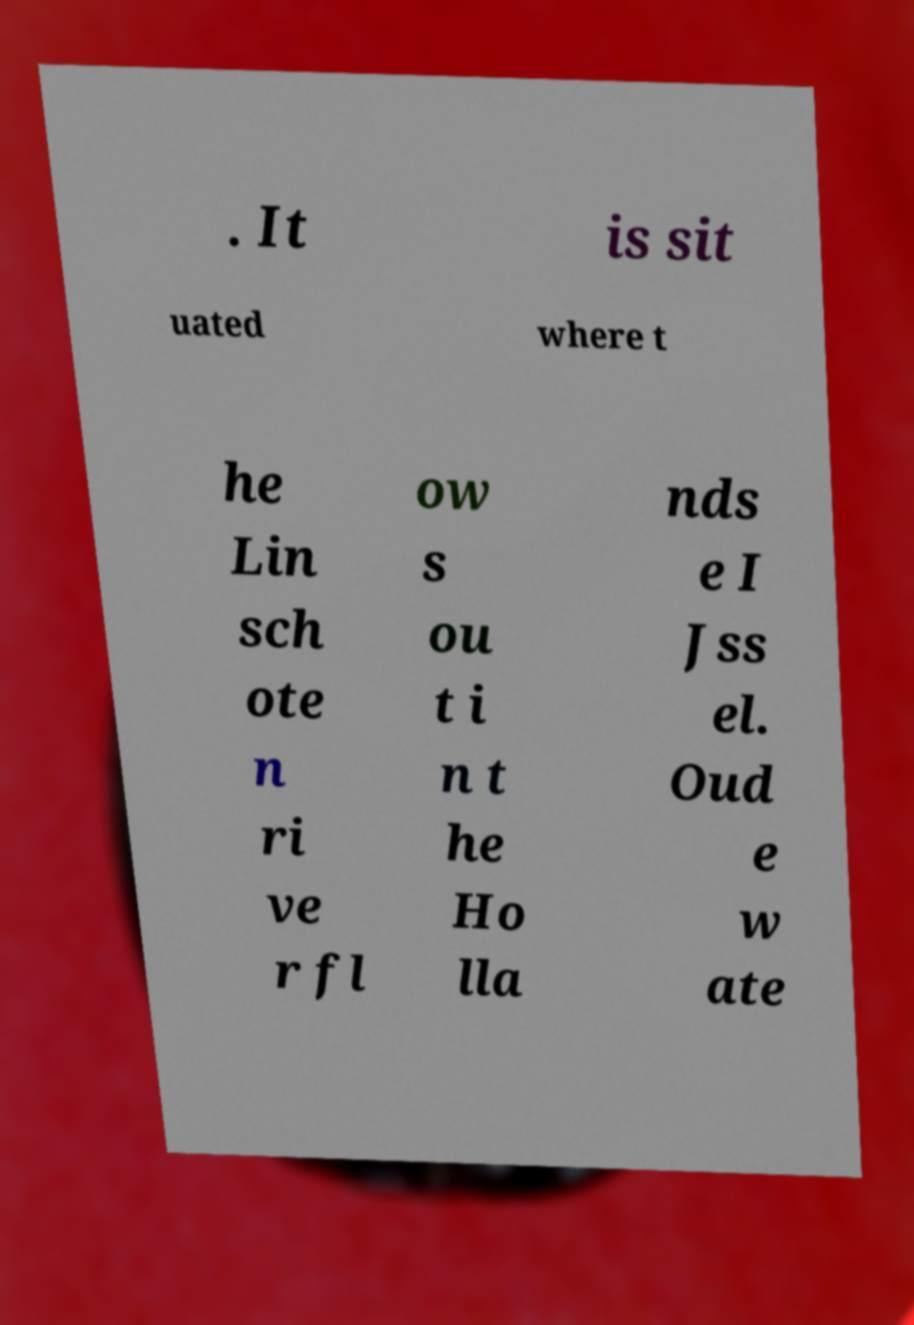Can you accurately transcribe the text from the provided image for me? . It is sit uated where t he Lin sch ote n ri ve r fl ow s ou t i n t he Ho lla nds e I Jss el. Oud e w ate 